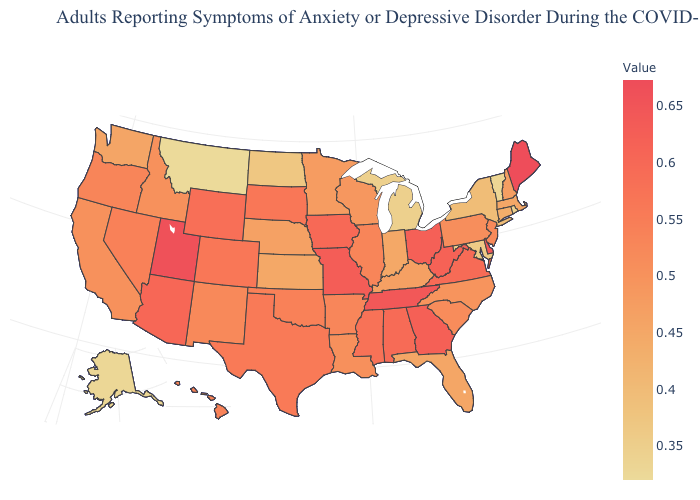Which states hav the highest value in the West?
Keep it brief. Utah. Among the states that border Tennessee , which have the highest value?
Keep it brief. Missouri. Does Arizona have the lowest value in the West?
Answer briefly. No. Does Maine have the highest value in the USA?
Keep it brief. Yes. Among the states that border Connecticut , does Massachusetts have the highest value?
Give a very brief answer. Yes. Does Montana have the lowest value in the West?
Short answer required. Yes. 